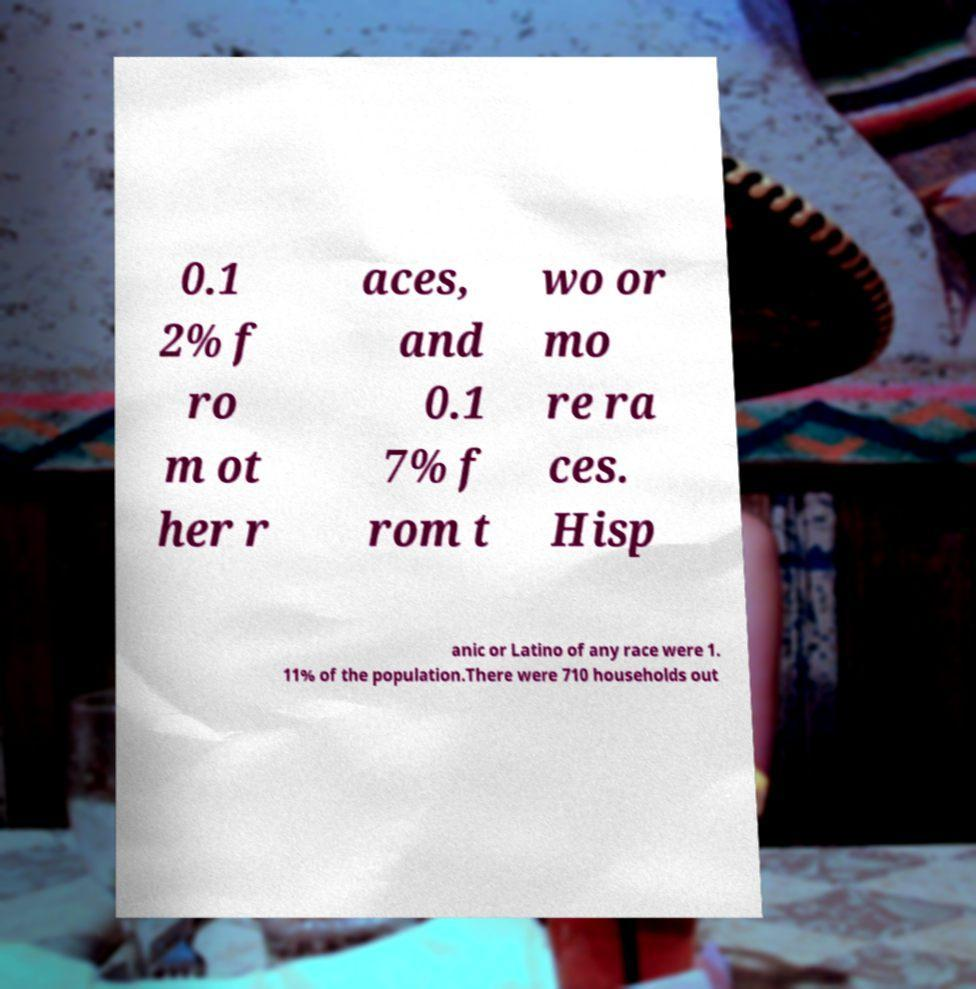Please identify and transcribe the text found in this image. 0.1 2% f ro m ot her r aces, and 0.1 7% f rom t wo or mo re ra ces. Hisp anic or Latino of any race were 1. 11% of the population.There were 710 households out 